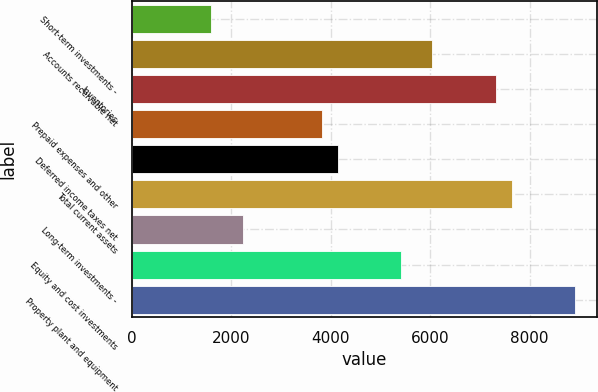Convert chart. <chart><loc_0><loc_0><loc_500><loc_500><bar_chart><fcel>Short-term investments -<fcel>Accounts receivable net<fcel>Inventories<fcel>Prepaid expenses and other<fcel>Deferred income taxes net<fcel>Total current assets<fcel>Long-term investments -<fcel>Equity and cost investments<fcel>Property plant and equipment<nl><fcel>1591.2<fcel>6044.6<fcel>7317<fcel>3817.9<fcel>4136<fcel>7635.1<fcel>2227.4<fcel>5408.4<fcel>8907.5<nl></chart> 